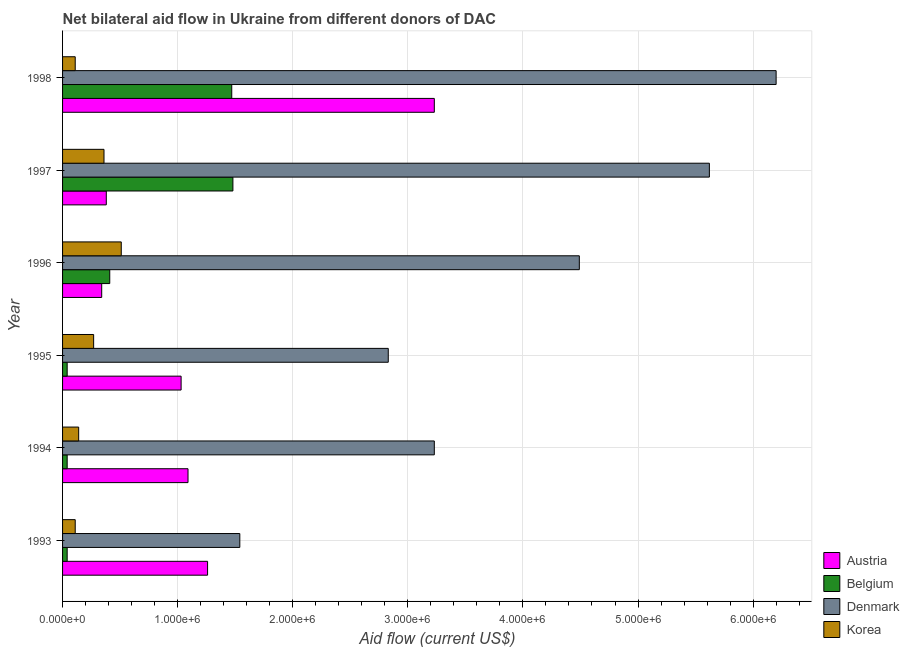Are the number of bars on each tick of the Y-axis equal?
Your answer should be very brief. Yes. What is the label of the 4th group of bars from the top?
Give a very brief answer. 1995. What is the amount of aid given by korea in 1997?
Provide a succinct answer. 3.60e+05. Across all years, what is the maximum amount of aid given by austria?
Ensure brevity in your answer.  3.23e+06. Across all years, what is the minimum amount of aid given by korea?
Offer a terse response. 1.10e+05. In which year was the amount of aid given by denmark maximum?
Your answer should be compact. 1998. What is the total amount of aid given by austria in the graph?
Make the answer very short. 7.33e+06. What is the difference between the amount of aid given by korea in 1993 and that in 1995?
Ensure brevity in your answer.  -1.60e+05. What is the difference between the amount of aid given by korea in 1997 and the amount of aid given by austria in 1994?
Ensure brevity in your answer.  -7.30e+05. What is the average amount of aid given by austria per year?
Give a very brief answer. 1.22e+06. In the year 1996, what is the difference between the amount of aid given by belgium and amount of aid given by denmark?
Offer a terse response. -4.08e+06. What is the ratio of the amount of aid given by austria in 1993 to that in 1996?
Your answer should be compact. 3.71. Is the difference between the amount of aid given by belgium in 1993 and 1996 greater than the difference between the amount of aid given by korea in 1993 and 1996?
Make the answer very short. Yes. What is the difference between the highest and the second highest amount of aid given by korea?
Offer a terse response. 1.50e+05. What is the difference between the highest and the lowest amount of aid given by korea?
Keep it short and to the point. 4.00e+05. Is the sum of the amount of aid given by austria in 1993 and 1995 greater than the maximum amount of aid given by korea across all years?
Your response must be concise. Yes. How many bars are there?
Offer a terse response. 24. Are all the bars in the graph horizontal?
Keep it short and to the point. Yes. What is the difference between two consecutive major ticks on the X-axis?
Keep it short and to the point. 1.00e+06. Are the values on the major ticks of X-axis written in scientific E-notation?
Provide a succinct answer. Yes. Does the graph contain grids?
Make the answer very short. Yes. Where does the legend appear in the graph?
Your response must be concise. Bottom right. What is the title of the graph?
Your answer should be compact. Net bilateral aid flow in Ukraine from different donors of DAC. Does "Periodicity assessment" appear as one of the legend labels in the graph?
Offer a terse response. No. What is the label or title of the Y-axis?
Offer a terse response. Year. What is the Aid flow (current US$) in Austria in 1993?
Ensure brevity in your answer.  1.26e+06. What is the Aid flow (current US$) in Belgium in 1993?
Keep it short and to the point. 4.00e+04. What is the Aid flow (current US$) of Denmark in 1993?
Offer a terse response. 1.54e+06. What is the Aid flow (current US$) of Austria in 1994?
Ensure brevity in your answer.  1.09e+06. What is the Aid flow (current US$) of Denmark in 1994?
Provide a succinct answer. 3.23e+06. What is the Aid flow (current US$) in Korea in 1994?
Keep it short and to the point. 1.40e+05. What is the Aid flow (current US$) of Austria in 1995?
Give a very brief answer. 1.03e+06. What is the Aid flow (current US$) of Belgium in 1995?
Offer a terse response. 4.00e+04. What is the Aid flow (current US$) of Denmark in 1995?
Keep it short and to the point. 2.83e+06. What is the Aid flow (current US$) in Denmark in 1996?
Provide a succinct answer. 4.49e+06. What is the Aid flow (current US$) in Korea in 1996?
Offer a terse response. 5.10e+05. What is the Aid flow (current US$) of Belgium in 1997?
Your answer should be compact. 1.48e+06. What is the Aid flow (current US$) of Denmark in 1997?
Offer a terse response. 5.62e+06. What is the Aid flow (current US$) of Austria in 1998?
Offer a terse response. 3.23e+06. What is the Aid flow (current US$) in Belgium in 1998?
Your answer should be compact. 1.47e+06. What is the Aid flow (current US$) of Denmark in 1998?
Ensure brevity in your answer.  6.20e+06. Across all years, what is the maximum Aid flow (current US$) in Austria?
Provide a short and direct response. 3.23e+06. Across all years, what is the maximum Aid flow (current US$) of Belgium?
Offer a terse response. 1.48e+06. Across all years, what is the maximum Aid flow (current US$) of Denmark?
Ensure brevity in your answer.  6.20e+06. Across all years, what is the maximum Aid flow (current US$) in Korea?
Provide a succinct answer. 5.10e+05. Across all years, what is the minimum Aid flow (current US$) in Belgium?
Your response must be concise. 4.00e+04. Across all years, what is the minimum Aid flow (current US$) in Denmark?
Your answer should be very brief. 1.54e+06. What is the total Aid flow (current US$) of Austria in the graph?
Offer a very short reply. 7.33e+06. What is the total Aid flow (current US$) of Belgium in the graph?
Your response must be concise. 3.48e+06. What is the total Aid flow (current US$) of Denmark in the graph?
Ensure brevity in your answer.  2.39e+07. What is the total Aid flow (current US$) in Korea in the graph?
Offer a very short reply. 1.50e+06. What is the difference between the Aid flow (current US$) of Belgium in 1993 and that in 1994?
Offer a terse response. 0. What is the difference between the Aid flow (current US$) of Denmark in 1993 and that in 1994?
Ensure brevity in your answer.  -1.69e+06. What is the difference between the Aid flow (current US$) of Austria in 1993 and that in 1995?
Your response must be concise. 2.30e+05. What is the difference between the Aid flow (current US$) in Denmark in 1993 and that in 1995?
Your answer should be compact. -1.29e+06. What is the difference between the Aid flow (current US$) in Korea in 1993 and that in 1995?
Your answer should be compact. -1.60e+05. What is the difference between the Aid flow (current US$) of Austria in 1993 and that in 1996?
Provide a succinct answer. 9.20e+05. What is the difference between the Aid flow (current US$) in Belgium in 1993 and that in 1996?
Make the answer very short. -3.70e+05. What is the difference between the Aid flow (current US$) of Denmark in 1993 and that in 1996?
Provide a succinct answer. -2.95e+06. What is the difference between the Aid flow (current US$) in Korea in 1993 and that in 1996?
Offer a very short reply. -4.00e+05. What is the difference between the Aid flow (current US$) in Austria in 1993 and that in 1997?
Your response must be concise. 8.80e+05. What is the difference between the Aid flow (current US$) of Belgium in 1993 and that in 1997?
Provide a succinct answer. -1.44e+06. What is the difference between the Aid flow (current US$) in Denmark in 1993 and that in 1997?
Your answer should be very brief. -4.08e+06. What is the difference between the Aid flow (current US$) in Austria in 1993 and that in 1998?
Provide a short and direct response. -1.97e+06. What is the difference between the Aid flow (current US$) in Belgium in 1993 and that in 1998?
Your response must be concise. -1.43e+06. What is the difference between the Aid flow (current US$) of Denmark in 1993 and that in 1998?
Give a very brief answer. -4.66e+06. What is the difference between the Aid flow (current US$) of Korea in 1993 and that in 1998?
Ensure brevity in your answer.  0. What is the difference between the Aid flow (current US$) of Belgium in 1994 and that in 1995?
Keep it short and to the point. 0. What is the difference between the Aid flow (current US$) in Korea in 1994 and that in 1995?
Offer a very short reply. -1.30e+05. What is the difference between the Aid flow (current US$) of Austria in 1994 and that in 1996?
Ensure brevity in your answer.  7.50e+05. What is the difference between the Aid flow (current US$) in Belgium in 1994 and that in 1996?
Give a very brief answer. -3.70e+05. What is the difference between the Aid flow (current US$) of Denmark in 1994 and that in 1996?
Provide a short and direct response. -1.26e+06. What is the difference between the Aid flow (current US$) in Korea in 1994 and that in 1996?
Offer a terse response. -3.70e+05. What is the difference between the Aid flow (current US$) of Austria in 1994 and that in 1997?
Offer a very short reply. 7.10e+05. What is the difference between the Aid flow (current US$) in Belgium in 1994 and that in 1997?
Provide a succinct answer. -1.44e+06. What is the difference between the Aid flow (current US$) in Denmark in 1994 and that in 1997?
Your response must be concise. -2.39e+06. What is the difference between the Aid flow (current US$) of Korea in 1994 and that in 1997?
Your response must be concise. -2.20e+05. What is the difference between the Aid flow (current US$) of Austria in 1994 and that in 1998?
Keep it short and to the point. -2.14e+06. What is the difference between the Aid flow (current US$) of Belgium in 1994 and that in 1998?
Your answer should be compact. -1.43e+06. What is the difference between the Aid flow (current US$) in Denmark in 1994 and that in 1998?
Provide a succinct answer. -2.97e+06. What is the difference between the Aid flow (current US$) of Austria in 1995 and that in 1996?
Keep it short and to the point. 6.90e+05. What is the difference between the Aid flow (current US$) of Belgium in 1995 and that in 1996?
Your response must be concise. -3.70e+05. What is the difference between the Aid flow (current US$) of Denmark in 1995 and that in 1996?
Your response must be concise. -1.66e+06. What is the difference between the Aid flow (current US$) of Korea in 1995 and that in 1996?
Keep it short and to the point. -2.40e+05. What is the difference between the Aid flow (current US$) of Austria in 1995 and that in 1997?
Your answer should be compact. 6.50e+05. What is the difference between the Aid flow (current US$) of Belgium in 1995 and that in 1997?
Provide a short and direct response. -1.44e+06. What is the difference between the Aid flow (current US$) of Denmark in 1995 and that in 1997?
Keep it short and to the point. -2.79e+06. What is the difference between the Aid flow (current US$) in Korea in 1995 and that in 1997?
Keep it short and to the point. -9.00e+04. What is the difference between the Aid flow (current US$) in Austria in 1995 and that in 1998?
Offer a terse response. -2.20e+06. What is the difference between the Aid flow (current US$) in Belgium in 1995 and that in 1998?
Ensure brevity in your answer.  -1.43e+06. What is the difference between the Aid flow (current US$) of Denmark in 1995 and that in 1998?
Keep it short and to the point. -3.37e+06. What is the difference between the Aid flow (current US$) in Austria in 1996 and that in 1997?
Offer a very short reply. -4.00e+04. What is the difference between the Aid flow (current US$) in Belgium in 1996 and that in 1997?
Keep it short and to the point. -1.07e+06. What is the difference between the Aid flow (current US$) in Denmark in 1996 and that in 1997?
Make the answer very short. -1.13e+06. What is the difference between the Aid flow (current US$) in Austria in 1996 and that in 1998?
Make the answer very short. -2.89e+06. What is the difference between the Aid flow (current US$) in Belgium in 1996 and that in 1998?
Offer a terse response. -1.06e+06. What is the difference between the Aid flow (current US$) of Denmark in 1996 and that in 1998?
Give a very brief answer. -1.71e+06. What is the difference between the Aid flow (current US$) in Austria in 1997 and that in 1998?
Provide a short and direct response. -2.85e+06. What is the difference between the Aid flow (current US$) in Belgium in 1997 and that in 1998?
Keep it short and to the point. 10000. What is the difference between the Aid flow (current US$) in Denmark in 1997 and that in 1998?
Your response must be concise. -5.80e+05. What is the difference between the Aid flow (current US$) of Austria in 1993 and the Aid flow (current US$) of Belgium in 1994?
Offer a terse response. 1.22e+06. What is the difference between the Aid flow (current US$) in Austria in 1993 and the Aid flow (current US$) in Denmark in 1994?
Provide a short and direct response. -1.97e+06. What is the difference between the Aid flow (current US$) of Austria in 1993 and the Aid flow (current US$) of Korea in 1994?
Ensure brevity in your answer.  1.12e+06. What is the difference between the Aid flow (current US$) of Belgium in 1993 and the Aid flow (current US$) of Denmark in 1994?
Give a very brief answer. -3.19e+06. What is the difference between the Aid flow (current US$) in Denmark in 1993 and the Aid flow (current US$) in Korea in 1994?
Provide a short and direct response. 1.40e+06. What is the difference between the Aid flow (current US$) in Austria in 1993 and the Aid flow (current US$) in Belgium in 1995?
Your response must be concise. 1.22e+06. What is the difference between the Aid flow (current US$) in Austria in 1993 and the Aid flow (current US$) in Denmark in 1995?
Your answer should be compact. -1.57e+06. What is the difference between the Aid flow (current US$) of Austria in 1993 and the Aid flow (current US$) of Korea in 1995?
Offer a very short reply. 9.90e+05. What is the difference between the Aid flow (current US$) in Belgium in 1993 and the Aid flow (current US$) in Denmark in 1995?
Offer a very short reply. -2.79e+06. What is the difference between the Aid flow (current US$) of Belgium in 1993 and the Aid flow (current US$) of Korea in 1995?
Provide a succinct answer. -2.30e+05. What is the difference between the Aid flow (current US$) in Denmark in 1993 and the Aid flow (current US$) in Korea in 1995?
Your answer should be compact. 1.27e+06. What is the difference between the Aid flow (current US$) of Austria in 1993 and the Aid flow (current US$) of Belgium in 1996?
Your response must be concise. 8.50e+05. What is the difference between the Aid flow (current US$) of Austria in 1993 and the Aid flow (current US$) of Denmark in 1996?
Your answer should be compact. -3.23e+06. What is the difference between the Aid flow (current US$) of Austria in 1993 and the Aid flow (current US$) of Korea in 1996?
Offer a terse response. 7.50e+05. What is the difference between the Aid flow (current US$) of Belgium in 1993 and the Aid flow (current US$) of Denmark in 1996?
Your answer should be very brief. -4.45e+06. What is the difference between the Aid flow (current US$) of Belgium in 1993 and the Aid flow (current US$) of Korea in 1996?
Give a very brief answer. -4.70e+05. What is the difference between the Aid flow (current US$) of Denmark in 1993 and the Aid flow (current US$) of Korea in 1996?
Offer a very short reply. 1.03e+06. What is the difference between the Aid flow (current US$) in Austria in 1993 and the Aid flow (current US$) in Denmark in 1997?
Keep it short and to the point. -4.36e+06. What is the difference between the Aid flow (current US$) of Austria in 1993 and the Aid flow (current US$) of Korea in 1997?
Make the answer very short. 9.00e+05. What is the difference between the Aid flow (current US$) in Belgium in 1993 and the Aid flow (current US$) in Denmark in 1997?
Ensure brevity in your answer.  -5.58e+06. What is the difference between the Aid flow (current US$) of Belgium in 1993 and the Aid flow (current US$) of Korea in 1997?
Keep it short and to the point. -3.20e+05. What is the difference between the Aid flow (current US$) in Denmark in 1993 and the Aid flow (current US$) in Korea in 1997?
Offer a terse response. 1.18e+06. What is the difference between the Aid flow (current US$) in Austria in 1993 and the Aid flow (current US$) in Belgium in 1998?
Your response must be concise. -2.10e+05. What is the difference between the Aid flow (current US$) in Austria in 1993 and the Aid flow (current US$) in Denmark in 1998?
Provide a succinct answer. -4.94e+06. What is the difference between the Aid flow (current US$) in Austria in 1993 and the Aid flow (current US$) in Korea in 1998?
Your answer should be compact. 1.15e+06. What is the difference between the Aid flow (current US$) of Belgium in 1993 and the Aid flow (current US$) of Denmark in 1998?
Provide a short and direct response. -6.16e+06. What is the difference between the Aid flow (current US$) of Denmark in 1993 and the Aid flow (current US$) of Korea in 1998?
Offer a very short reply. 1.43e+06. What is the difference between the Aid flow (current US$) in Austria in 1994 and the Aid flow (current US$) in Belgium in 1995?
Make the answer very short. 1.05e+06. What is the difference between the Aid flow (current US$) in Austria in 1994 and the Aid flow (current US$) in Denmark in 1995?
Provide a short and direct response. -1.74e+06. What is the difference between the Aid flow (current US$) in Austria in 1994 and the Aid flow (current US$) in Korea in 1995?
Provide a succinct answer. 8.20e+05. What is the difference between the Aid flow (current US$) of Belgium in 1994 and the Aid flow (current US$) of Denmark in 1995?
Provide a succinct answer. -2.79e+06. What is the difference between the Aid flow (current US$) in Belgium in 1994 and the Aid flow (current US$) in Korea in 1995?
Your answer should be very brief. -2.30e+05. What is the difference between the Aid flow (current US$) of Denmark in 1994 and the Aid flow (current US$) of Korea in 1995?
Offer a terse response. 2.96e+06. What is the difference between the Aid flow (current US$) in Austria in 1994 and the Aid flow (current US$) in Belgium in 1996?
Make the answer very short. 6.80e+05. What is the difference between the Aid flow (current US$) of Austria in 1994 and the Aid flow (current US$) of Denmark in 1996?
Your answer should be compact. -3.40e+06. What is the difference between the Aid flow (current US$) in Austria in 1994 and the Aid flow (current US$) in Korea in 1996?
Your response must be concise. 5.80e+05. What is the difference between the Aid flow (current US$) in Belgium in 1994 and the Aid flow (current US$) in Denmark in 1996?
Offer a very short reply. -4.45e+06. What is the difference between the Aid flow (current US$) of Belgium in 1994 and the Aid flow (current US$) of Korea in 1996?
Provide a succinct answer. -4.70e+05. What is the difference between the Aid flow (current US$) in Denmark in 1994 and the Aid flow (current US$) in Korea in 1996?
Offer a very short reply. 2.72e+06. What is the difference between the Aid flow (current US$) in Austria in 1994 and the Aid flow (current US$) in Belgium in 1997?
Your response must be concise. -3.90e+05. What is the difference between the Aid flow (current US$) of Austria in 1994 and the Aid flow (current US$) of Denmark in 1997?
Keep it short and to the point. -4.53e+06. What is the difference between the Aid flow (current US$) of Austria in 1994 and the Aid flow (current US$) of Korea in 1997?
Offer a terse response. 7.30e+05. What is the difference between the Aid flow (current US$) in Belgium in 1994 and the Aid flow (current US$) in Denmark in 1997?
Make the answer very short. -5.58e+06. What is the difference between the Aid flow (current US$) of Belgium in 1994 and the Aid flow (current US$) of Korea in 1997?
Offer a very short reply. -3.20e+05. What is the difference between the Aid flow (current US$) in Denmark in 1994 and the Aid flow (current US$) in Korea in 1997?
Keep it short and to the point. 2.87e+06. What is the difference between the Aid flow (current US$) in Austria in 1994 and the Aid flow (current US$) in Belgium in 1998?
Provide a succinct answer. -3.80e+05. What is the difference between the Aid flow (current US$) in Austria in 1994 and the Aid flow (current US$) in Denmark in 1998?
Make the answer very short. -5.11e+06. What is the difference between the Aid flow (current US$) in Austria in 1994 and the Aid flow (current US$) in Korea in 1998?
Your answer should be compact. 9.80e+05. What is the difference between the Aid flow (current US$) of Belgium in 1994 and the Aid flow (current US$) of Denmark in 1998?
Your answer should be compact. -6.16e+06. What is the difference between the Aid flow (current US$) of Belgium in 1994 and the Aid flow (current US$) of Korea in 1998?
Keep it short and to the point. -7.00e+04. What is the difference between the Aid flow (current US$) of Denmark in 1994 and the Aid flow (current US$) of Korea in 1998?
Ensure brevity in your answer.  3.12e+06. What is the difference between the Aid flow (current US$) of Austria in 1995 and the Aid flow (current US$) of Belgium in 1996?
Keep it short and to the point. 6.20e+05. What is the difference between the Aid flow (current US$) of Austria in 1995 and the Aid flow (current US$) of Denmark in 1996?
Make the answer very short. -3.46e+06. What is the difference between the Aid flow (current US$) in Austria in 1995 and the Aid flow (current US$) in Korea in 1996?
Make the answer very short. 5.20e+05. What is the difference between the Aid flow (current US$) in Belgium in 1995 and the Aid flow (current US$) in Denmark in 1996?
Offer a very short reply. -4.45e+06. What is the difference between the Aid flow (current US$) of Belgium in 1995 and the Aid flow (current US$) of Korea in 1996?
Provide a succinct answer. -4.70e+05. What is the difference between the Aid flow (current US$) of Denmark in 1995 and the Aid flow (current US$) of Korea in 1996?
Your answer should be compact. 2.32e+06. What is the difference between the Aid flow (current US$) of Austria in 1995 and the Aid flow (current US$) of Belgium in 1997?
Your answer should be very brief. -4.50e+05. What is the difference between the Aid flow (current US$) of Austria in 1995 and the Aid flow (current US$) of Denmark in 1997?
Your answer should be compact. -4.59e+06. What is the difference between the Aid flow (current US$) in Austria in 1995 and the Aid flow (current US$) in Korea in 1997?
Provide a short and direct response. 6.70e+05. What is the difference between the Aid flow (current US$) of Belgium in 1995 and the Aid flow (current US$) of Denmark in 1997?
Your response must be concise. -5.58e+06. What is the difference between the Aid flow (current US$) in Belgium in 1995 and the Aid flow (current US$) in Korea in 1997?
Provide a succinct answer. -3.20e+05. What is the difference between the Aid flow (current US$) of Denmark in 1995 and the Aid flow (current US$) of Korea in 1997?
Your answer should be compact. 2.47e+06. What is the difference between the Aid flow (current US$) in Austria in 1995 and the Aid flow (current US$) in Belgium in 1998?
Give a very brief answer. -4.40e+05. What is the difference between the Aid flow (current US$) of Austria in 1995 and the Aid flow (current US$) of Denmark in 1998?
Make the answer very short. -5.17e+06. What is the difference between the Aid flow (current US$) in Austria in 1995 and the Aid flow (current US$) in Korea in 1998?
Offer a very short reply. 9.20e+05. What is the difference between the Aid flow (current US$) of Belgium in 1995 and the Aid flow (current US$) of Denmark in 1998?
Make the answer very short. -6.16e+06. What is the difference between the Aid flow (current US$) of Belgium in 1995 and the Aid flow (current US$) of Korea in 1998?
Keep it short and to the point. -7.00e+04. What is the difference between the Aid flow (current US$) in Denmark in 1995 and the Aid flow (current US$) in Korea in 1998?
Your response must be concise. 2.72e+06. What is the difference between the Aid flow (current US$) in Austria in 1996 and the Aid flow (current US$) in Belgium in 1997?
Provide a short and direct response. -1.14e+06. What is the difference between the Aid flow (current US$) in Austria in 1996 and the Aid flow (current US$) in Denmark in 1997?
Your answer should be very brief. -5.28e+06. What is the difference between the Aid flow (current US$) of Belgium in 1996 and the Aid flow (current US$) of Denmark in 1997?
Keep it short and to the point. -5.21e+06. What is the difference between the Aid flow (current US$) of Denmark in 1996 and the Aid flow (current US$) of Korea in 1997?
Your answer should be compact. 4.13e+06. What is the difference between the Aid flow (current US$) in Austria in 1996 and the Aid flow (current US$) in Belgium in 1998?
Your response must be concise. -1.13e+06. What is the difference between the Aid flow (current US$) of Austria in 1996 and the Aid flow (current US$) of Denmark in 1998?
Ensure brevity in your answer.  -5.86e+06. What is the difference between the Aid flow (current US$) of Austria in 1996 and the Aid flow (current US$) of Korea in 1998?
Your answer should be compact. 2.30e+05. What is the difference between the Aid flow (current US$) of Belgium in 1996 and the Aid flow (current US$) of Denmark in 1998?
Provide a short and direct response. -5.79e+06. What is the difference between the Aid flow (current US$) of Belgium in 1996 and the Aid flow (current US$) of Korea in 1998?
Provide a short and direct response. 3.00e+05. What is the difference between the Aid flow (current US$) of Denmark in 1996 and the Aid flow (current US$) of Korea in 1998?
Your response must be concise. 4.38e+06. What is the difference between the Aid flow (current US$) in Austria in 1997 and the Aid flow (current US$) in Belgium in 1998?
Make the answer very short. -1.09e+06. What is the difference between the Aid flow (current US$) in Austria in 1997 and the Aid flow (current US$) in Denmark in 1998?
Your answer should be compact. -5.82e+06. What is the difference between the Aid flow (current US$) of Austria in 1997 and the Aid flow (current US$) of Korea in 1998?
Your answer should be very brief. 2.70e+05. What is the difference between the Aid flow (current US$) in Belgium in 1997 and the Aid flow (current US$) in Denmark in 1998?
Keep it short and to the point. -4.72e+06. What is the difference between the Aid flow (current US$) of Belgium in 1997 and the Aid flow (current US$) of Korea in 1998?
Provide a succinct answer. 1.37e+06. What is the difference between the Aid flow (current US$) in Denmark in 1997 and the Aid flow (current US$) in Korea in 1998?
Provide a succinct answer. 5.51e+06. What is the average Aid flow (current US$) in Austria per year?
Your answer should be compact. 1.22e+06. What is the average Aid flow (current US$) in Belgium per year?
Offer a very short reply. 5.80e+05. What is the average Aid flow (current US$) in Denmark per year?
Offer a terse response. 3.98e+06. In the year 1993, what is the difference between the Aid flow (current US$) of Austria and Aid flow (current US$) of Belgium?
Offer a very short reply. 1.22e+06. In the year 1993, what is the difference between the Aid flow (current US$) in Austria and Aid flow (current US$) in Denmark?
Provide a short and direct response. -2.80e+05. In the year 1993, what is the difference between the Aid flow (current US$) of Austria and Aid flow (current US$) of Korea?
Provide a succinct answer. 1.15e+06. In the year 1993, what is the difference between the Aid flow (current US$) of Belgium and Aid flow (current US$) of Denmark?
Provide a short and direct response. -1.50e+06. In the year 1993, what is the difference between the Aid flow (current US$) of Denmark and Aid flow (current US$) of Korea?
Make the answer very short. 1.43e+06. In the year 1994, what is the difference between the Aid flow (current US$) of Austria and Aid flow (current US$) of Belgium?
Give a very brief answer. 1.05e+06. In the year 1994, what is the difference between the Aid flow (current US$) of Austria and Aid flow (current US$) of Denmark?
Give a very brief answer. -2.14e+06. In the year 1994, what is the difference between the Aid flow (current US$) of Austria and Aid flow (current US$) of Korea?
Offer a terse response. 9.50e+05. In the year 1994, what is the difference between the Aid flow (current US$) of Belgium and Aid flow (current US$) of Denmark?
Your response must be concise. -3.19e+06. In the year 1994, what is the difference between the Aid flow (current US$) in Denmark and Aid flow (current US$) in Korea?
Offer a terse response. 3.09e+06. In the year 1995, what is the difference between the Aid flow (current US$) in Austria and Aid flow (current US$) in Belgium?
Provide a short and direct response. 9.90e+05. In the year 1995, what is the difference between the Aid flow (current US$) in Austria and Aid flow (current US$) in Denmark?
Your answer should be very brief. -1.80e+06. In the year 1995, what is the difference between the Aid flow (current US$) in Austria and Aid flow (current US$) in Korea?
Your response must be concise. 7.60e+05. In the year 1995, what is the difference between the Aid flow (current US$) of Belgium and Aid flow (current US$) of Denmark?
Provide a short and direct response. -2.79e+06. In the year 1995, what is the difference between the Aid flow (current US$) in Belgium and Aid flow (current US$) in Korea?
Your answer should be compact. -2.30e+05. In the year 1995, what is the difference between the Aid flow (current US$) of Denmark and Aid flow (current US$) of Korea?
Your response must be concise. 2.56e+06. In the year 1996, what is the difference between the Aid flow (current US$) of Austria and Aid flow (current US$) of Belgium?
Your response must be concise. -7.00e+04. In the year 1996, what is the difference between the Aid flow (current US$) of Austria and Aid flow (current US$) of Denmark?
Make the answer very short. -4.15e+06. In the year 1996, what is the difference between the Aid flow (current US$) of Austria and Aid flow (current US$) of Korea?
Your answer should be compact. -1.70e+05. In the year 1996, what is the difference between the Aid flow (current US$) of Belgium and Aid flow (current US$) of Denmark?
Offer a terse response. -4.08e+06. In the year 1996, what is the difference between the Aid flow (current US$) of Belgium and Aid flow (current US$) of Korea?
Make the answer very short. -1.00e+05. In the year 1996, what is the difference between the Aid flow (current US$) of Denmark and Aid flow (current US$) of Korea?
Your response must be concise. 3.98e+06. In the year 1997, what is the difference between the Aid flow (current US$) in Austria and Aid flow (current US$) in Belgium?
Your answer should be very brief. -1.10e+06. In the year 1997, what is the difference between the Aid flow (current US$) in Austria and Aid flow (current US$) in Denmark?
Your answer should be compact. -5.24e+06. In the year 1997, what is the difference between the Aid flow (current US$) of Belgium and Aid flow (current US$) of Denmark?
Your response must be concise. -4.14e+06. In the year 1997, what is the difference between the Aid flow (current US$) in Belgium and Aid flow (current US$) in Korea?
Ensure brevity in your answer.  1.12e+06. In the year 1997, what is the difference between the Aid flow (current US$) in Denmark and Aid flow (current US$) in Korea?
Keep it short and to the point. 5.26e+06. In the year 1998, what is the difference between the Aid flow (current US$) in Austria and Aid flow (current US$) in Belgium?
Ensure brevity in your answer.  1.76e+06. In the year 1998, what is the difference between the Aid flow (current US$) of Austria and Aid flow (current US$) of Denmark?
Provide a succinct answer. -2.97e+06. In the year 1998, what is the difference between the Aid flow (current US$) of Austria and Aid flow (current US$) of Korea?
Keep it short and to the point. 3.12e+06. In the year 1998, what is the difference between the Aid flow (current US$) of Belgium and Aid flow (current US$) of Denmark?
Give a very brief answer. -4.73e+06. In the year 1998, what is the difference between the Aid flow (current US$) of Belgium and Aid flow (current US$) of Korea?
Your answer should be compact. 1.36e+06. In the year 1998, what is the difference between the Aid flow (current US$) of Denmark and Aid flow (current US$) of Korea?
Provide a short and direct response. 6.09e+06. What is the ratio of the Aid flow (current US$) of Austria in 1993 to that in 1994?
Provide a short and direct response. 1.16. What is the ratio of the Aid flow (current US$) in Belgium in 1993 to that in 1994?
Your answer should be compact. 1. What is the ratio of the Aid flow (current US$) of Denmark in 1993 to that in 1994?
Make the answer very short. 0.48. What is the ratio of the Aid flow (current US$) of Korea in 1993 to that in 1994?
Keep it short and to the point. 0.79. What is the ratio of the Aid flow (current US$) of Austria in 1993 to that in 1995?
Ensure brevity in your answer.  1.22. What is the ratio of the Aid flow (current US$) in Denmark in 1993 to that in 1995?
Provide a short and direct response. 0.54. What is the ratio of the Aid flow (current US$) in Korea in 1993 to that in 1995?
Offer a very short reply. 0.41. What is the ratio of the Aid flow (current US$) in Austria in 1993 to that in 1996?
Your response must be concise. 3.71. What is the ratio of the Aid flow (current US$) of Belgium in 1993 to that in 1996?
Ensure brevity in your answer.  0.1. What is the ratio of the Aid flow (current US$) in Denmark in 1993 to that in 1996?
Provide a succinct answer. 0.34. What is the ratio of the Aid flow (current US$) in Korea in 1993 to that in 1996?
Make the answer very short. 0.22. What is the ratio of the Aid flow (current US$) in Austria in 1993 to that in 1997?
Your answer should be compact. 3.32. What is the ratio of the Aid flow (current US$) in Belgium in 1993 to that in 1997?
Offer a very short reply. 0.03. What is the ratio of the Aid flow (current US$) in Denmark in 1993 to that in 1997?
Ensure brevity in your answer.  0.27. What is the ratio of the Aid flow (current US$) in Korea in 1993 to that in 1997?
Your response must be concise. 0.31. What is the ratio of the Aid flow (current US$) of Austria in 1993 to that in 1998?
Your answer should be compact. 0.39. What is the ratio of the Aid flow (current US$) of Belgium in 1993 to that in 1998?
Your answer should be very brief. 0.03. What is the ratio of the Aid flow (current US$) of Denmark in 1993 to that in 1998?
Offer a very short reply. 0.25. What is the ratio of the Aid flow (current US$) in Korea in 1993 to that in 1998?
Provide a short and direct response. 1. What is the ratio of the Aid flow (current US$) of Austria in 1994 to that in 1995?
Your response must be concise. 1.06. What is the ratio of the Aid flow (current US$) in Denmark in 1994 to that in 1995?
Provide a succinct answer. 1.14. What is the ratio of the Aid flow (current US$) in Korea in 1994 to that in 1995?
Offer a very short reply. 0.52. What is the ratio of the Aid flow (current US$) of Austria in 1994 to that in 1996?
Make the answer very short. 3.21. What is the ratio of the Aid flow (current US$) of Belgium in 1994 to that in 1996?
Keep it short and to the point. 0.1. What is the ratio of the Aid flow (current US$) in Denmark in 1994 to that in 1996?
Offer a very short reply. 0.72. What is the ratio of the Aid flow (current US$) of Korea in 1994 to that in 1996?
Provide a short and direct response. 0.27. What is the ratio of the Aid flow (current US$) of Austria in 1994 to that in 1997?
Give a very brief answer. 2.87. What is the ratio of the Aid flow (current US$) of Belgium in 1994 to that in 1997?
Keep it short and to the point. 0.03. What is the ratio of the Aid flow (current US$) of Denmark in 1994 to that in 1997?
Provide a short and direct response. 0.57. What is the ratio of the Aid flow (current US$) in Korea in 1994 to that in 1997?
Offer a very short reply. 0.39. What is the ratio of the Aid flow (current US$) of Austria in 1994 to that in 1998?
Make the answer very short. 0.34. What is the ratio of the Aid flow (current US$) in Belgium in 1994 to that in 1998?
Give a very brief answer. 0.03. What is the ratio of the Aid flow (current US$) in Denmark in 1994 to that in 1998?
Provide a succinct answer. 0.52. What is the ratio of the Aid flow (current US$) in Korea in 1994 to that in 1998?
Ensure brevity in your answer.  1.27. What is the ratio of the Aid flow (current US$) of Austria in 1995 to that in 1996?
Offer a very short reply. 3.03. What is the ratio of the Aid flow (current US$) of Belgium in 1995 to that in 1996?
Make the answer very short. 0.1. What is the ratio of the Aid flow (current US$) in Denmark in 1995 to that in 1996?
Provide a succinct answer. 0.63. What is the ratio of the Aid flow (current US$) in Korea in 1995 to that in 1996?
Your answer should be very brief. 0.53. What is the ratio of the Aid flow (current US$) of Austria in 1995 to that in 1997?
Provide a short and direct response. 2.71. What is the ratio of the Aid flow (current US$) in Belgium in 1995 to that in 1997?
Your answer should be very brief. 0.03. What is the ratio of the Aid flow (current US$) of Denmark in 1995 to that in 1997?
Make the answer very short. 0.5. What is the ratio of the Aid flow (current US$) of Austria in 1995 to that in 1998?
Your response must be concise. 0.32. What is the ratio of the Aid flow (current US$) of Belgium in 1995 to that in 1998?
Ensure brevity in your answer.  0.03. What is the ratio of the Aid flow (current US$) of Denmark in 1995 to that in 1998?
Provide a short and direct response. 0.46. What is the ratio of the Aid flow (current US$) in Korea in 1995 to that in 1998?
Give a very brief answer. 2.45. What is the ratio of the Aid flow (current US$) in Austria in 1996 to that in 1997?
Your answer should be compact. 0.89. What is the ratio of the Aid flow (current US$) in Belgium in 1996 to that in 1997?
Keep it short and to the point. 0.28. What is the ratio of the Aid flow (current US$) in Denmark in 1996 to that in 1997?
Offer a very short reply. 0.8. What is the ratio of the Aid flow (current US$) in Korea in 1996 to that in 1997?
Make the answer very short. 1.42. What is the ratio of the Aid flow (current US$) in Austria in 1996 to that in 1998?
Ensure brevity in your answer.  0.11. What is the ratio of the Aid flow (current US$) in Belgium in 1996 to that in 1998?
Provide a succinct answer. 0.28. What is the ratio of the Aid flow (current US$) in Denmark in 1996 to that in 1998?
Provide a short and direct response. 0.72. What is the ratio of the Aid flow (current US$) in Korea in 1996 to that in 1998?
Your answer should be very brief. 4.64. What is the ratio of the Aid flow (current US$) of Austria in 1997 to that in 1998?
Ensure brevity in your answer.  0.12. What is the ratio of the Aid flow (current US$) in Belgium in 1997 to that in 1998?
Your answer should be very brief. 1.01. What is the ratio of the Aid flow (current US$) of Denmark in 1997 to that in 1998?
Offer a very short reply. 0.91. What is the ratio of the Aid flow (current US$) of Korea in 1997 to that in 1998?
Make the answer very short. 3.27. What is the difference between the highest and the second highest Aid flow (current US$) in Austria?
Ensure brevity in your answer.  1.97e+06. What is the difference between the highest and the second highest Aid flow (current US$) in Belgium?
Make the answer very short. 10000. What is the difference between the highest and the second highest Aid flow (current US$) of Denmark?
Your response must be concise. 5.80e+05. What is the difference between the highest and the lowest Aid flow (current US$) in Austria?
Your answer should be compact. 2.89e+06. What is the difference between the highest and the lowest Aid flow (current US$) of Belgium?
Provide a short and direct response. 1.44e+06. What is the difference between the highest and the lowest Aid flow (current US$) in Denmark?
Give a very brief answer. 4.66e+06. 